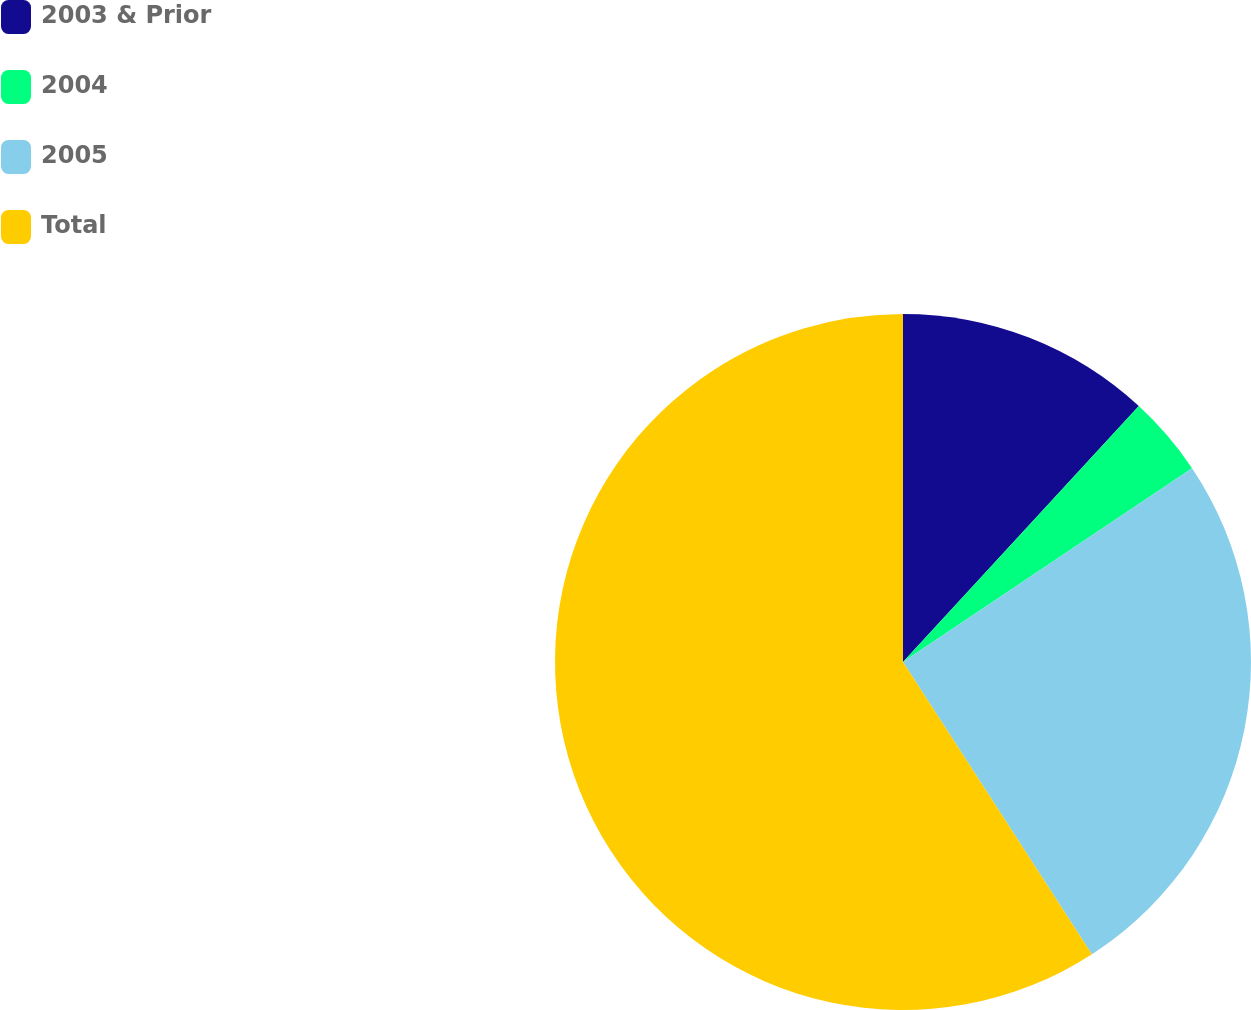Convert chart. <chart><loc_0><loc_0><loc_500><loc_500><pie_chart><fcel>2003 & Prior<fcel>2004<fcel>2005<fcel>Total<nl><fcel>11.85%<fcel>3.75%<fcel>25.27%<fcel>59.13%<nl></chart> 